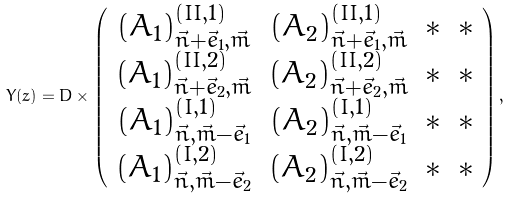Convert formula to latex. <formula><loc_0><loc_0><loc_500><loc_500>Y ( z ) = D \times \left ( \begin{array} { c c c c } ( A _ { 1 } ) _ { \vec { n } + \vec { e } _ { 1 } , \vec { m } } ^ { ( I I , 1 ) } & ( A _ { 2 } ) _ { \vec { n } + \vec { e } _ { 1 } , \vec { m } } ^ { ( I I , 1 ) } & * & * \\ ( A _ { 1 } ) _ { \vec { n } + \vec { e } _ { 2 } , \vec { m } } ^ { ( I I , 2 ) } & ( A _ { 2 } ) _ { \vec { n } + \vec { e } _ { 2 } , \vec { m } } ^ { ( I I , 2 ) } & * & * \\ ( A _ { 1 } ) _ { \vec { n } , \vec { m } - \vec { e } _ { 1 } } ^ { ( I , 1 ) } & ( A _ { 2 } ) _ { \vec { n } , \vec { m } - \vec { e } _ { 1 } } ^ { ( I , 1 ) } & * & * \\ ( A _ { 1 } ) _ { \vec { n } , \vec { m } - \vec { e } _ { 2 } } ^ { ( I , 2 ) } & ( A _ { 2 } ) _ { \vec { n } , \vec { m } - \vec { e } _ { 2 } } ^ { ( I , 2 ) } & * & * \\ \end{array} \right ) ,</formula> 